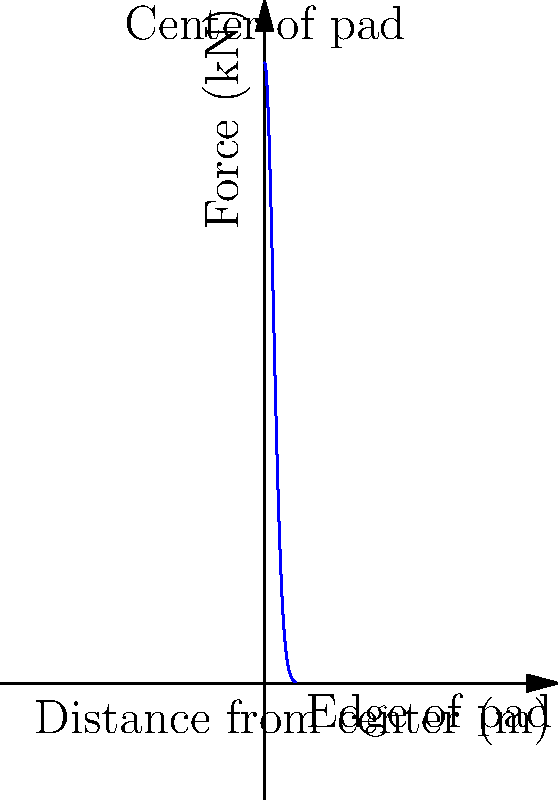During a lunar landing, the force distribution on a circular landing pad follows an exponential decay pattern from the center to the edge, as shown in the graph. If the maximum force at the center is 100 kN and the pad radius is 5 m, at what distance from the center is the force reduced to 50 kN? To solve this problem, we need to follow these steps:

1) The force distribution is given by the equation:
   $$F(x) = F_{max} \cdot e^{-kx^2}$$
   where $F_{max}$ is the maximum force at the center, $x$ is the distance from the center, and $k$ is a constant.

2) We know that $F_{max} = 100$ kN, so our equation becomes:
   $$F(x) = 100 \cdot e^{-kx^2}$$

3) We need to find $k$ using the information that the force at the edge (5 m) is close to zero. Let's assume it's 1% of the maximum force:
   $$1 = 100 \cdot e^{-k(5^2)}$$
   $$0.01 = e^{-25k}$$
   $$\ln(0.01) = -25k$$
   $$k = \frac{-\ln(0.01)}{25} \approx 0.18$$

4) Now our equation is:
   $$F(x) = 100 \cdot e^{-0.18x^2}$$

5) We want to find $x$ when $F(x) = 50$ kN:
   $$50 = 100 \cdot e^{-0.18x^2}$$
   $$0.5 = e^{-0.18x^2}$$
   $$\ln(0.5) = -0.18x^2$$
   $$x^2 = \frac{-\ln(0.5)}{0.18} \approx 3.85$$
   $$x \approx 1.96$$

Therefore, the force is reduced to 50 kN at approximately 1.96 m from the center of the pad.
Answer: 1.96 m 